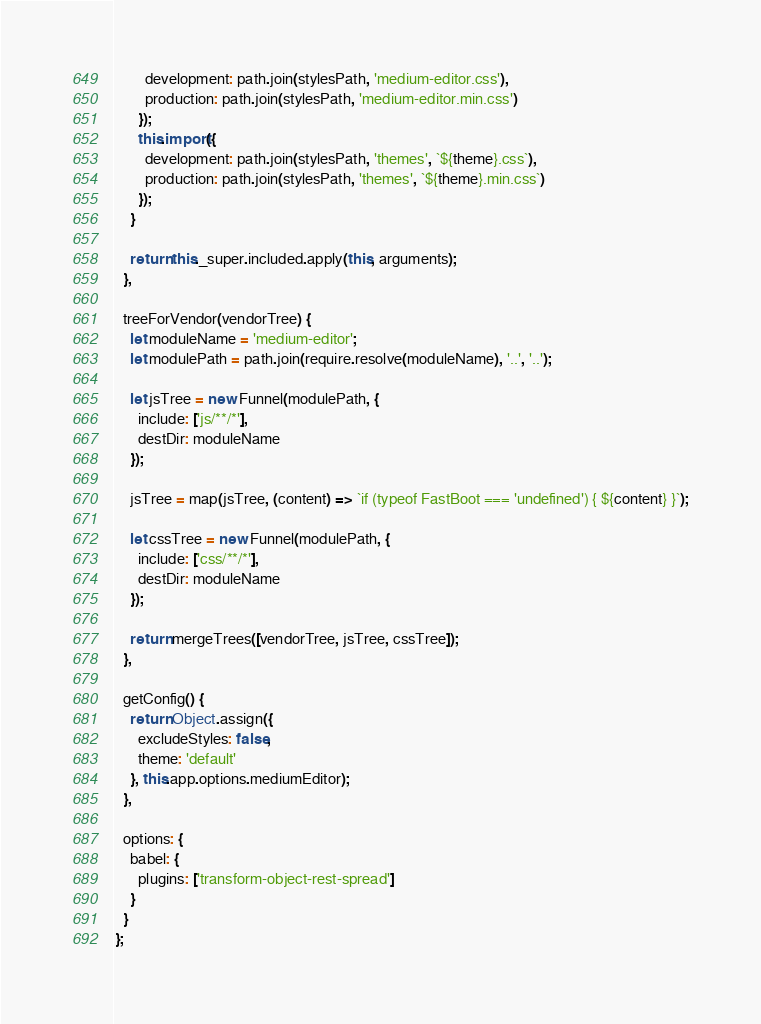<code> <loc_0><loc_0><loc_500><loc_500><_JavaScript_>        development: path.join(stylesPath, 'medium-editor.css'),
        production: path.join(stylesPath, 'medium-editor.min.css')
      });
      this.import({
        development: path.join(stylesPath, 'themes', `${theme}.css`),
        production: path.join(stylesPath, 'themes', `${theme}.min.css`)
      });
    }

    return this._super.included.apply(this, arguments);
  },

  treeForVendor(vendorTree) {
    let moduleName = 'medium-editor';
    let modulePath = path.join(require.resolve(moduleName), '..', '..');

    let jsTree = new Funnel(modulePath, {
      include: ['js/**/*'],
      destDir: moduleName
    });

    jsTree = map(jsTree, (content) => `if (typeof FastBoot === 'undefined') { ${content} }`);

    let cssTree = new Funnel(modulePath, {
      include: ['css/**/*'],
      destDir: moduleName
    });

    return mergeTrees([vendorTree, jsTree, cssTree]);
  },

  getConfig() {
    return Object.assign({
      excludeStyles: false,
      theme: 'default'
    }, this.app.options.mediumEditor);
  },

  options: {
    babel: {
      plugins: ['transform-object-rest-spread']
    }
  }
};
</code> 